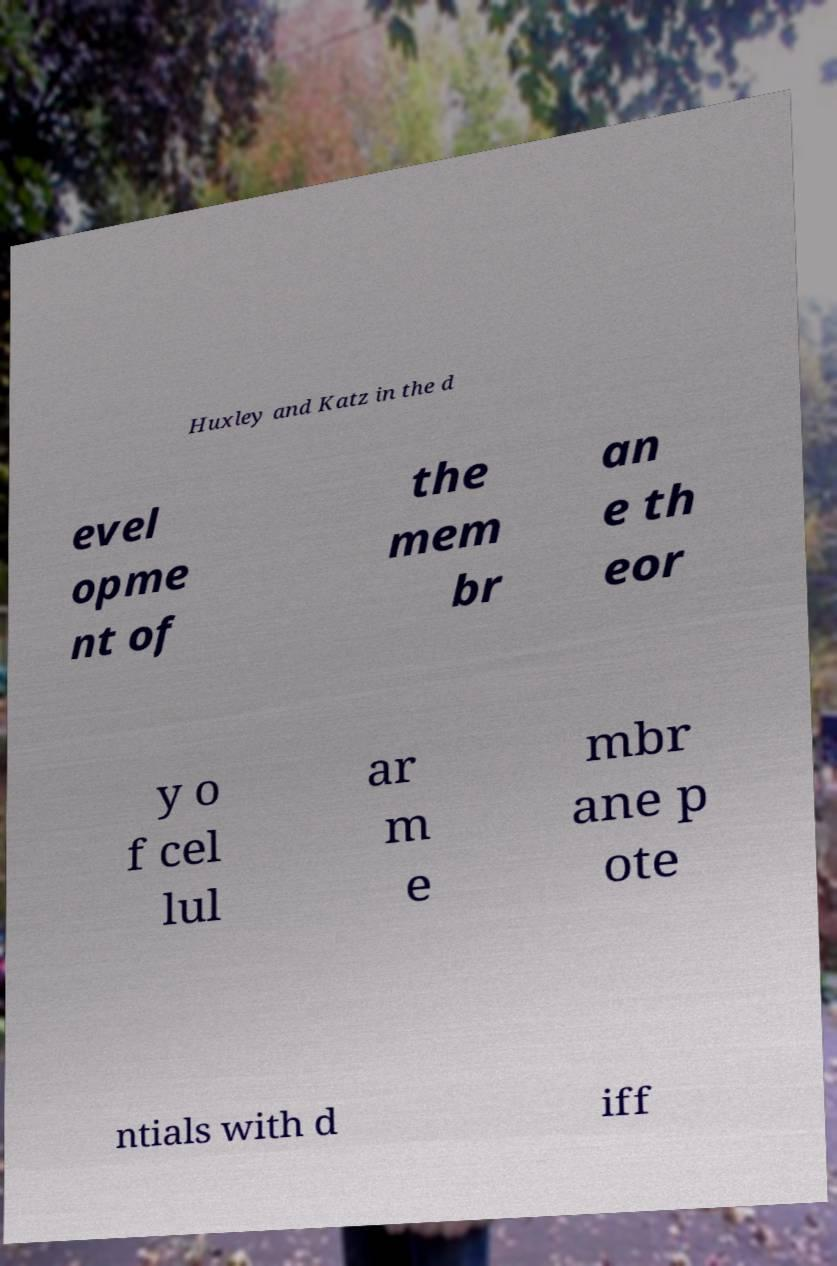Please identify and transcribe the text found in this image. Huxley and Katz in the d evel opme nt of the mem br an e th eor y o f cel lul ar m e mbr ane p ote ntials with d iff 